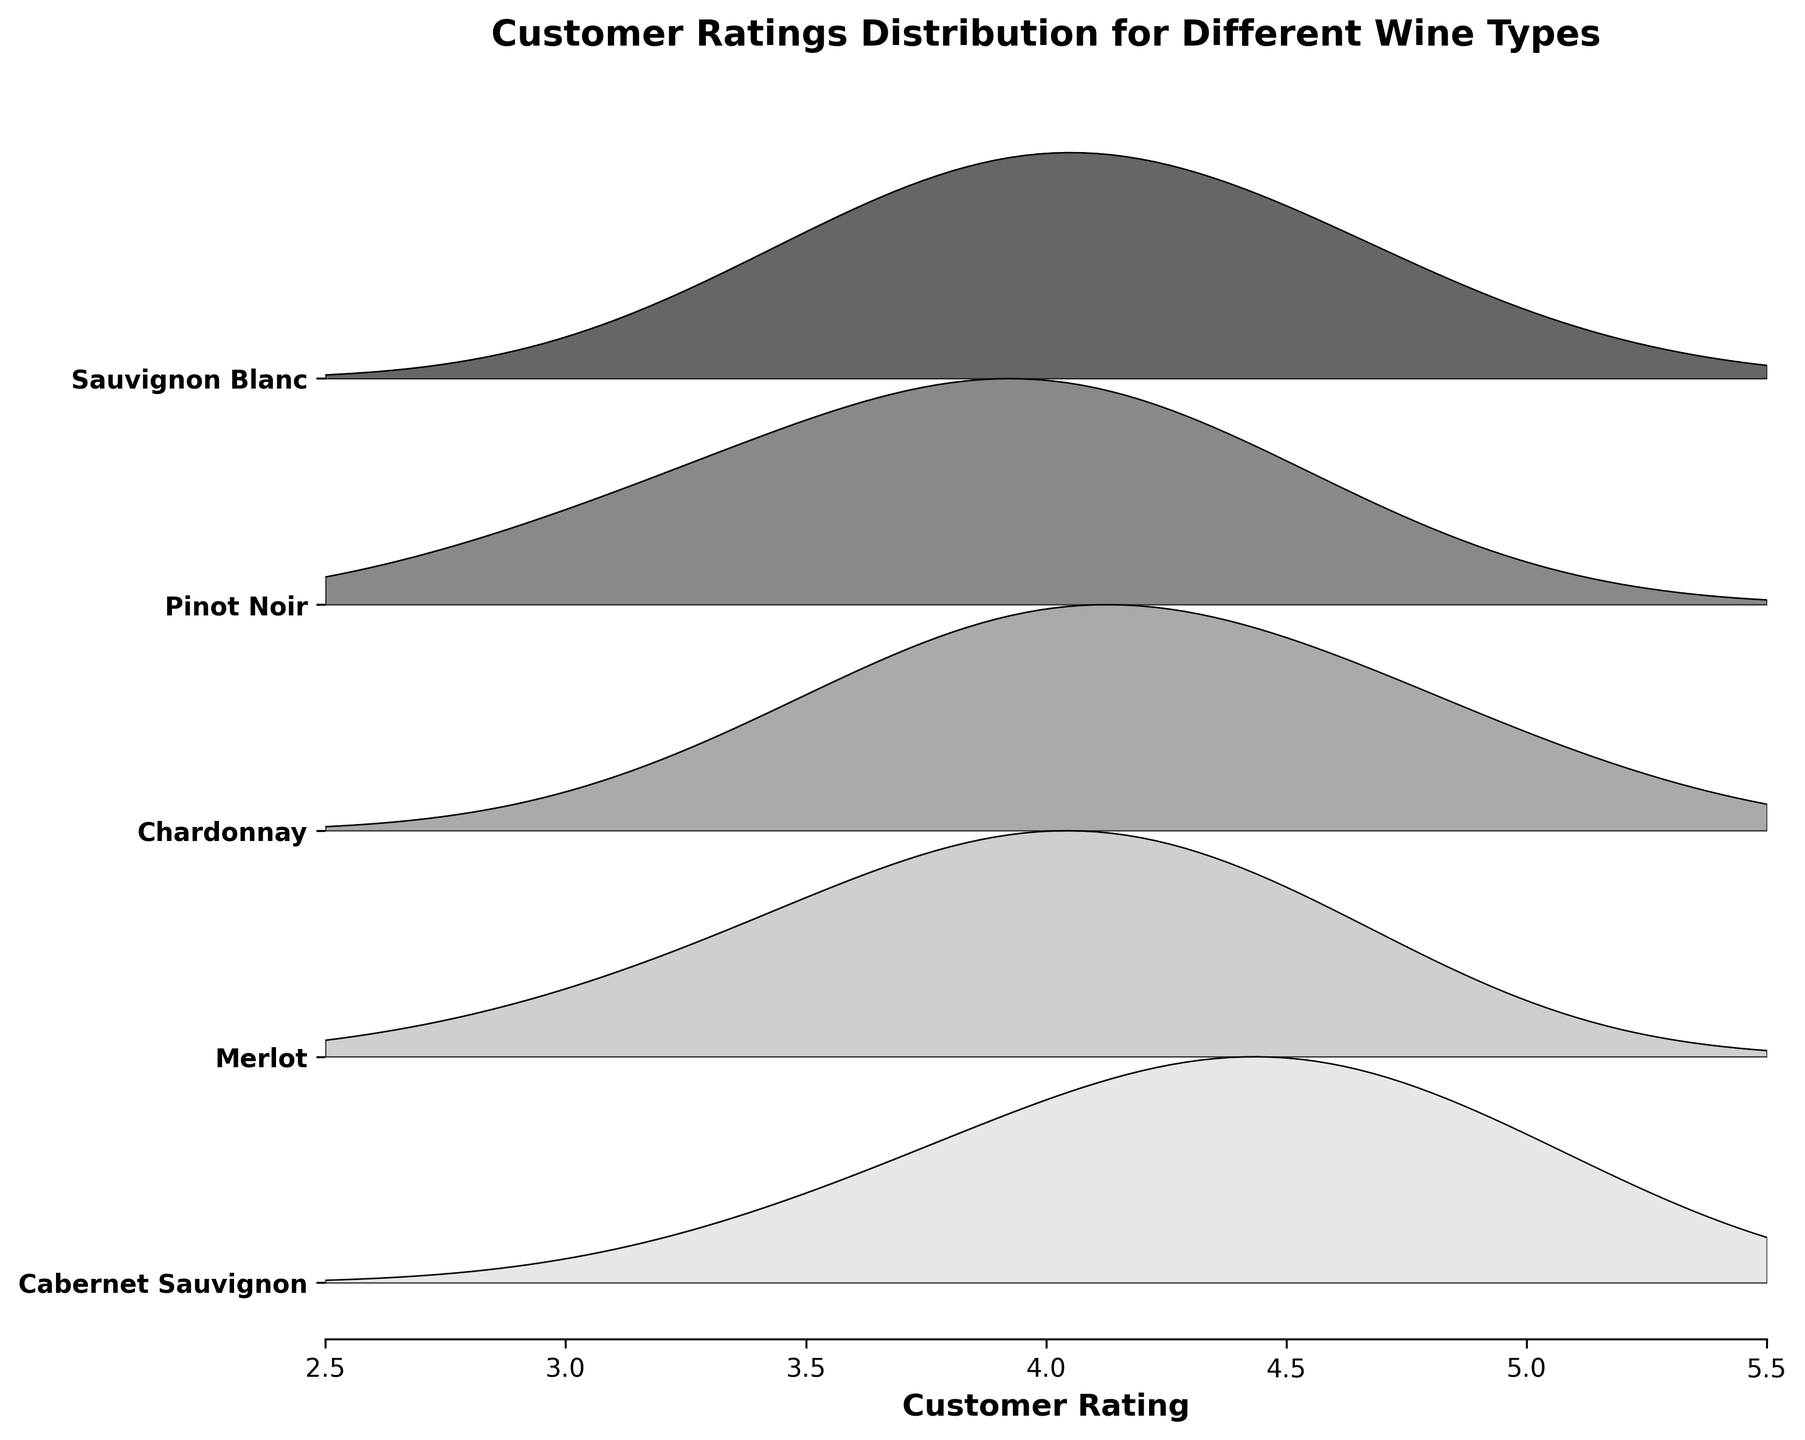What's the title of the figure? The title of the figure is located at the top of the plot and usually describes the overall theme of the data being visualized. In this case, it reads 'Customer Ratings Distribution for Different Wine Types'.
Answer: Customer Ratings Distribution for Different Wine Types How many types of wines are displayed in the plot? The plot has tick labels along the y-axis representing different wine types. Counting these labels will provide the total number of wine types in the plot.
Answer: 5 Which wine type has the highest density for the customer rating of 4.0? To identify the wine type with the highest density at a specific customer rating, examine the peaks at that rating. The biggest peak for the rating of 4.0 corresponds to the "Sauvignon Blanc" wine type in the plot.
Answer: Sauvignon Blanc What's the maximum density value for Merlot, 2016? To find this, look at the curve for Merlot in 2016 and find the highest point. The plot shows the densities along the 'density' dimension, indicating that the maximum density value for Merlot for this vintage is 0.06.
Answer: 0.06 Which wine type has the most uniform distribution of customer ratings? A uniform distribution would have a flatter curve across the rating range without sharp peaks. Examining the plot reveals that "Chardonnay" has a relatively uniform distribution, with densities spread across ratings.
Answer: Chardonnay Which wine type shows a peak near a customer rating of 5.0? To spot this, examine the plot for peaks close to the rating of 5.0. "Chardonnay" shows a noticeable peak near 5.0, indicated by a higher density at this rating.
Answer: Chardonnay For wine types of the same ratings, which year has the highest density for Sauvignon Blanc? To determine this, look at the y-axis label corresponding to Sauvignon Blanc and locate the rating with the peak density. In the plot, Sauvignon Blanc for 2019 at rating 4.0 has the highest density.
Answer: 2019 Which wine types have a rating interval that includes ratings lower than 4.0 and higher than 4.5? Check the plot for wine types with density curves extending both below 4.0 and above 4.5. "Merlot," "Pinot Noir," and "Chardonnay" have density curves covering ratings below 4.0 and above 4.5.
Answer: Merlot, Pinot Noir, Chardonnay Which wine type generally received the lowest customer ratings according to the plot? This involves observing which wine type's peak density values are located towards the lower end of the rating scale. Based on the plot, "Merlot" and "Pinot Noir" have peaks closer to lower customer ratings.
Answer: Merlot, Pinot Noir 